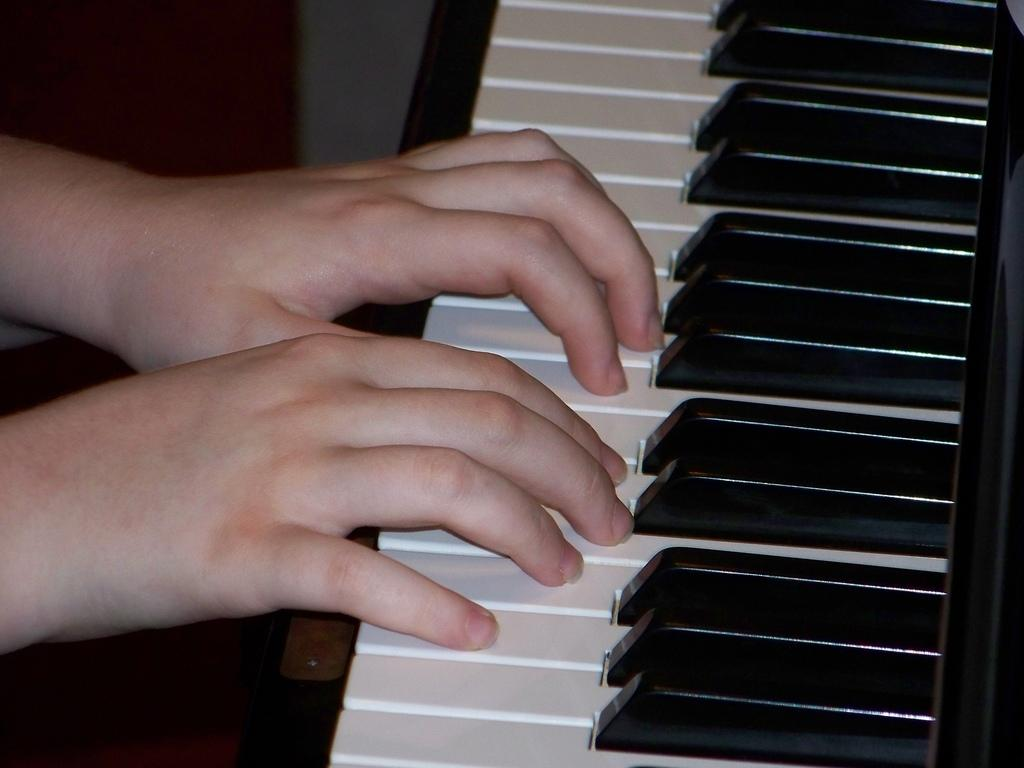What is the main activity being performed in the image? There is a person playing piano in the image. Where is the piano located in the image? The piano is on the right side of the image. What part of the person is visible while playing the piano? There are hands on the piano in the image. What type of insurance policy is being discussed by the person playing the piano? There is no indication in the image that a discussion about insurance is taking place. 